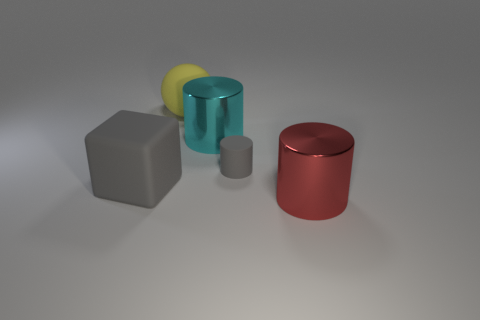Add 1 large rubber things. How many objects exist? 6 Subtract all cubes. How many objects are left? 4 Add 4 big cyan things. How many big cyan things exist? 5 Subtract 1 yellow balls. How many objects are left? 4 Subtract all blue matte cubes. Subtract all big yellow rubber objects. How many objects are left? 4 Add 3 metallic cylinders. How many metallic cylinders are left? 5 